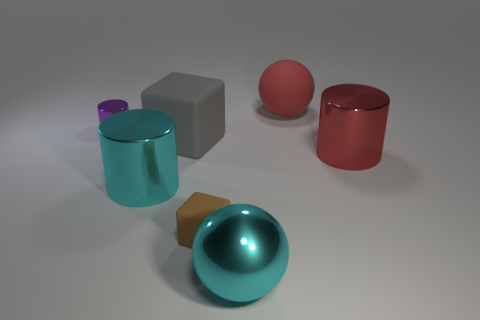What number of big metal objects have the same color as the big metal ball?
Keep it short and to the point. 1. There is a cyan thing that is the same size as the metallic ball; what material is it?
Ensure brevity in your answer.  Metal. How many tiny things are either brown rubber things or shiny blocks?
Offer a very short reply. 1. Is the small purple metallic thing the same shape as the red metallic thing?
Your response must be concise. Yes. How many metal cylinders are in front of the gray cube and on the left side of the gray rubber block?
Your response must be concise. 1. Are there any other things that have the same color as the tiny rubber cube?
Offer a very short reply. No. There is a large red object that is made of the same material as the tiny purple cylinder; what shape is it?
Offer a terse response. Cylinder. Does the metal ball have the same size as the gray cube?
Ensure brevity in your answer.  Yes. Are the tiny thing that is in front of the small purple shiny thing and the large gray thing made of the same material?
Give a very brief answer. Yes. Is there anything else that has the same material as the brown object?
Provide a short and direct response. Yes. 